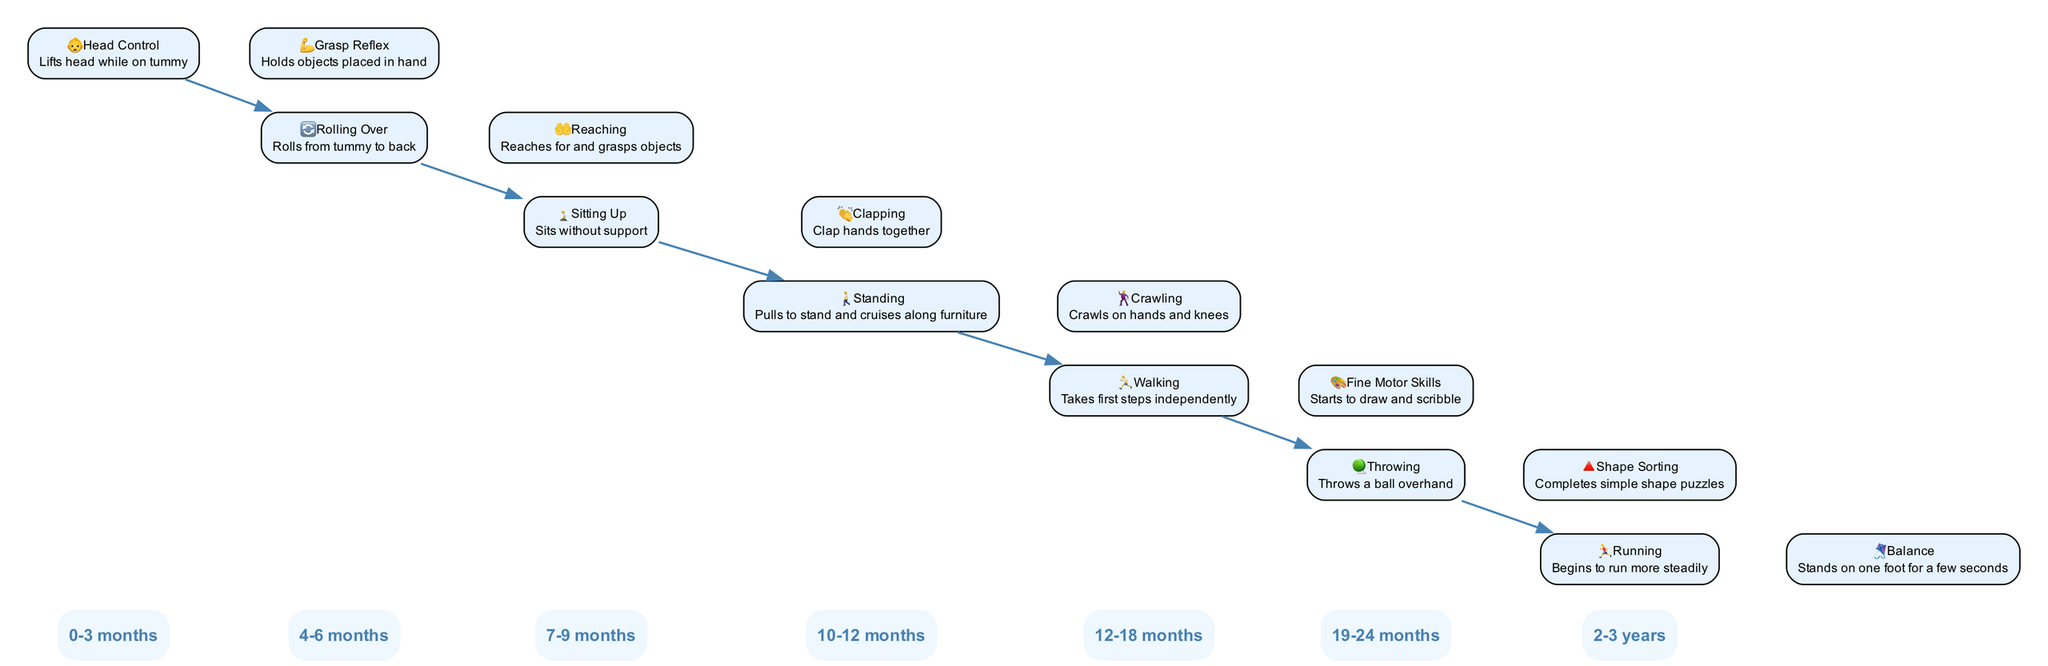What age range does "Clapping" correspond to in the diagram? "Clapping" is one of the milestones listed under the age range of 7-9 months in the timeline. By locating the milestone text in that segment, we can directly confirm the age range for this milestone.
Answer: 7-9 months How many milestones are shown for the age group 12-18 months? There are two milestones listed in the 12-18 months age group: "Walking" and "Fine Motor Skills." Counting these milestones confirms the total directly from the diagram.
Answer: 2 What is the relationship between "Standing" and the previous milestone in the timeline? "Standing" occurs in the 10-12 months age group and follows "Sitting Up" from the previous age group (7-9 months). Since the "Standing" milestone is connected directly from "Sitting Up," it shows a progression in physical development.
Answer: Progression Which milestone indicates the first independent motion in the diagram? The milestone labeled "Walking" in the 12-18 months age range describes taking the first steps independently. By reading through the milestones, we see this specific phrasing indicating the first independent locomotion.
Answer: Walking What is the icon associated with the "Throwing" milestone? The icon next to the "Throwing" milestone in the 19-24 months age range is "🪀." We can determine this by locating the milestone on the timeline and observing the corresponding icon.
Answer: 🪀 What is the last milestone displayed on the timeline? The final milestone is "Balance," which is associated with the 2-3 years age group. Reviewing the timeline structure reveals that this is the last item related to child development milestones illustrated in the diagram.
Answer: Balance 